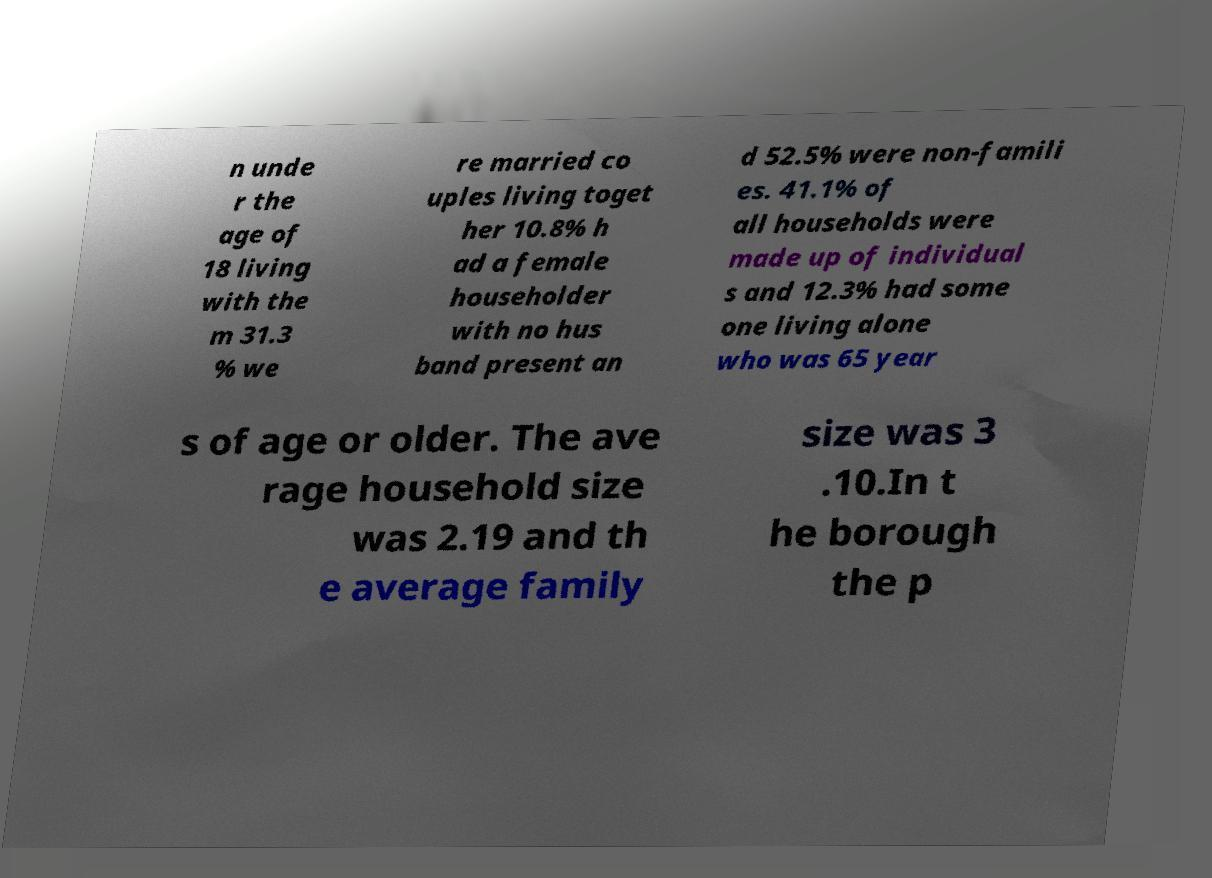Can you read and provide the text displayed in the image?This photo seems to have some interesting text. Can you extract and type it out for me? n unde r the age of 18 living with the m 31.3 % we re married co uples living toget her 10.8% h ad a female householder with no hus band present an d 52.5% were non-famili es. 41.1% of all households were made up of individual s and 12.3% had some one living alone who was 65 year s of age or older. The ave rage household size was 2.19 and th e average family size was 3 .10.In t he borough the p 